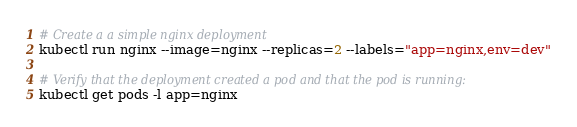<code> <loc_0><loc_0><loc_500><loc_500><_Bash_># Create a a simple nginx deployment
kubectl run nginx --image=nginx --replicas=2 --labels="app=nginx,env=dev"

# Verify that the deployment created a pod and that the pod is running:
kubectl get pods -l app=nginx
</code> 